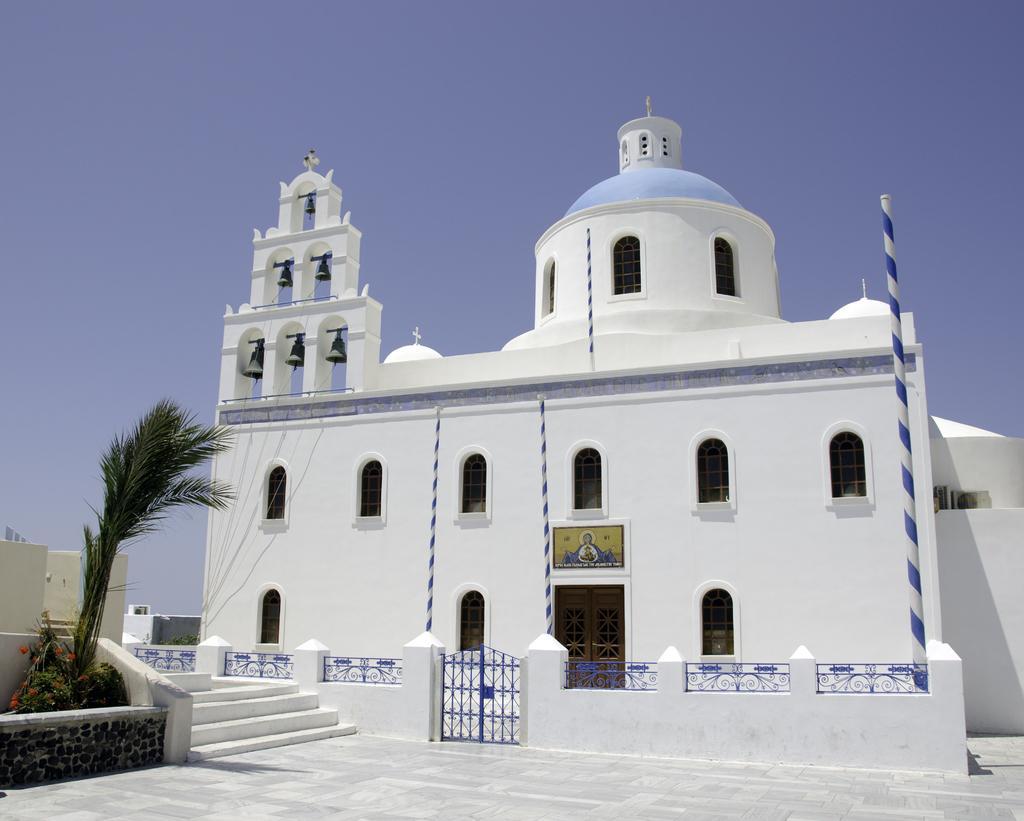In one or two sentences, can you explain what this image depicts? In this picture which look like a church. On the left I can see the stairs, plants, trees and wall. At the bottom there is a gate. Beside that I can see the fencing on the wall. In the back I can see the windows and door. At the top I can see the sky. 